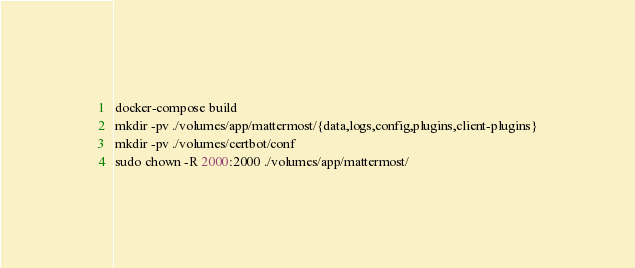Convert code to text. <code><loc_0><loc_0><loc_500><loc_500><_Bash_>docker-compose build
mkdir -pv ./volumes/app/mattermost/{data,logs,config,plugins,client-plugins}
mkdir -pv ./volumes/certbot/conf
sudo chown -R 2000:2000 ./volumes/app/mattermost/
</code> 